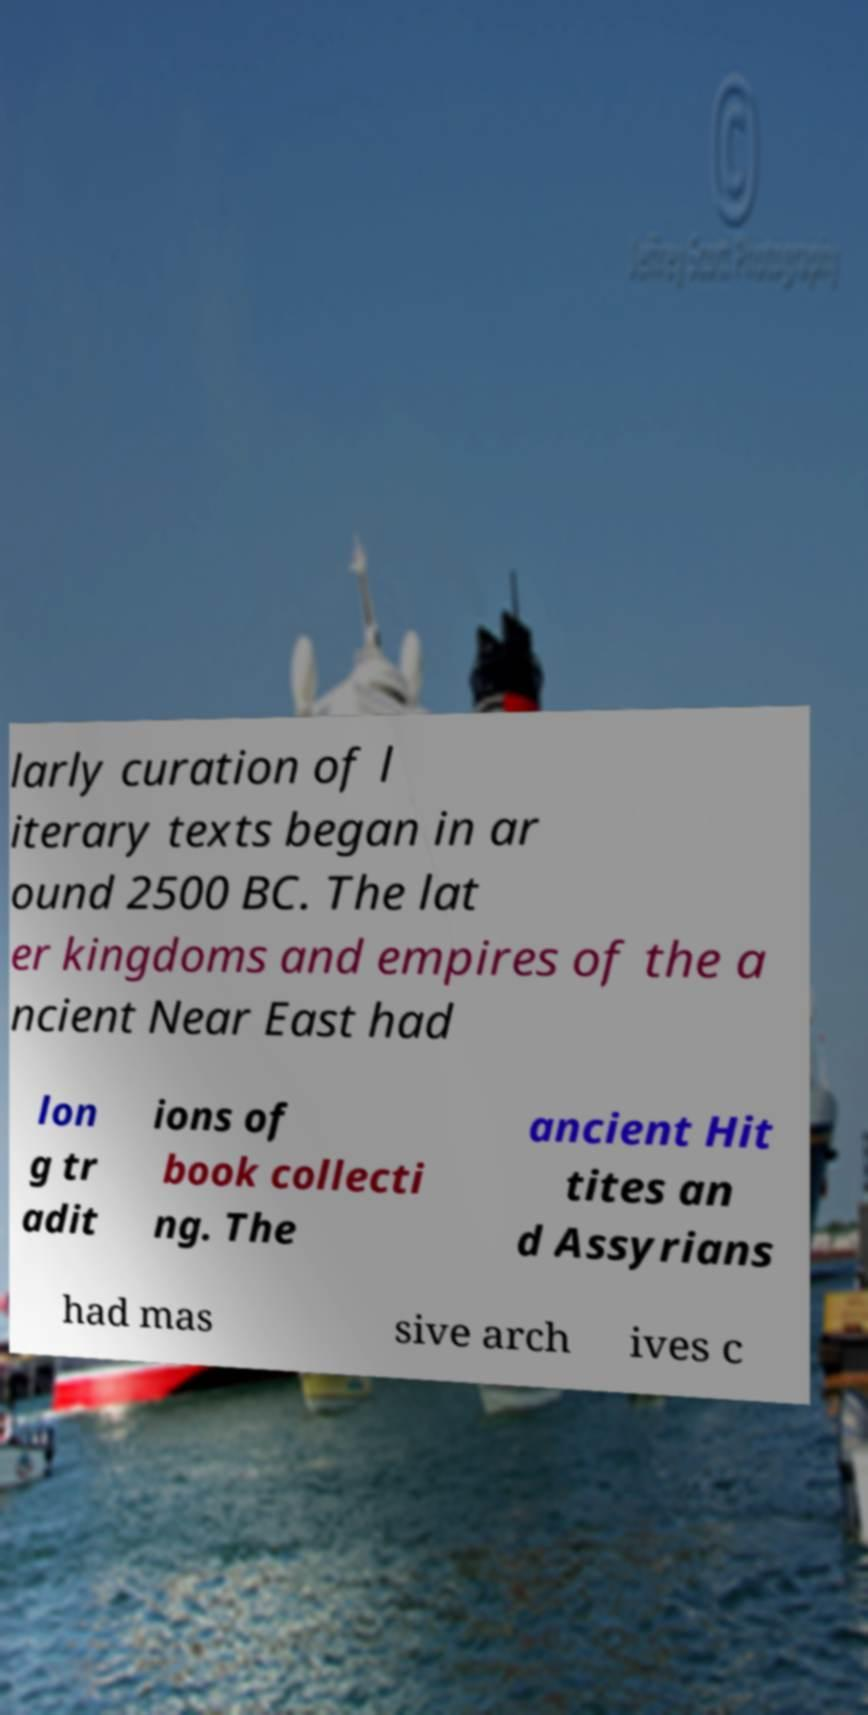Could you assist in decoding the text presented in this image and type it out clearly? larly curation of l iterary texts began in ar ound 2500 BC. The lat er kingdoms and empires of the a ncient Near East had lon g tr adit ions of book collecti ng. The ancient Hit tites an d Assyrians had mas sive arch ives c 